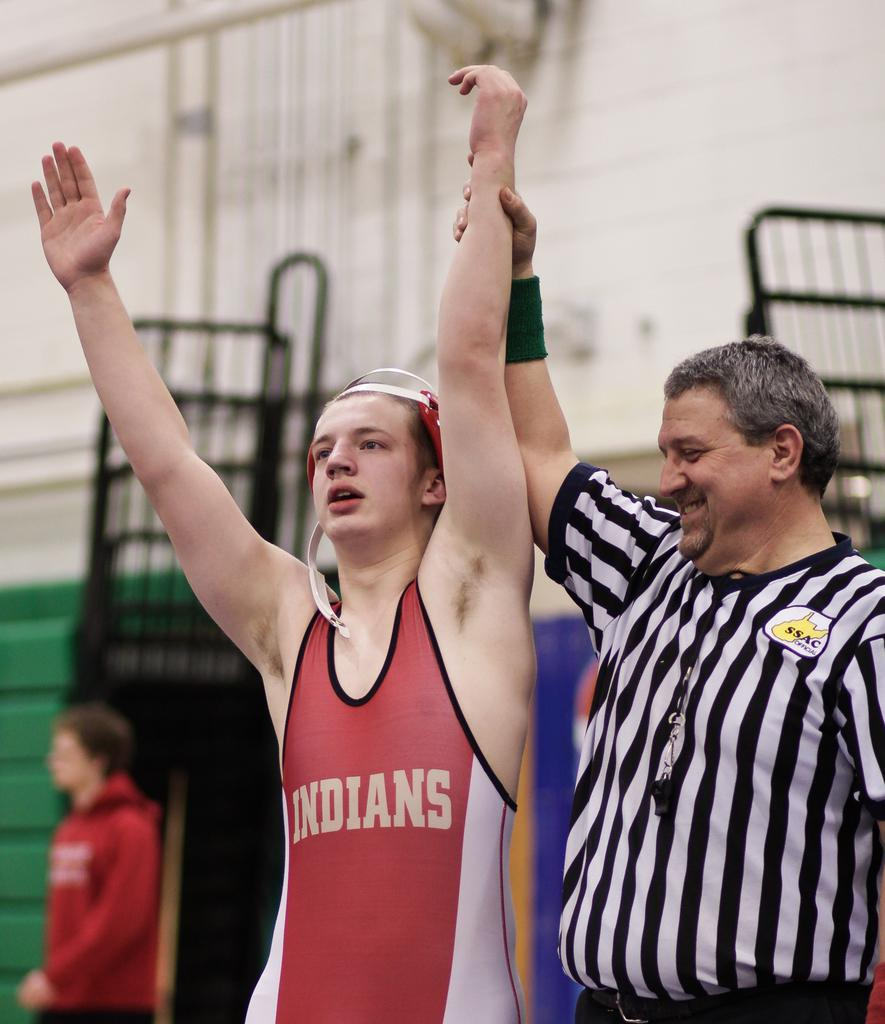<image>
Render a clear and concise summary of the photo. An SSAC official referee holds the hand of a wrestler from the Indians high in the air. 